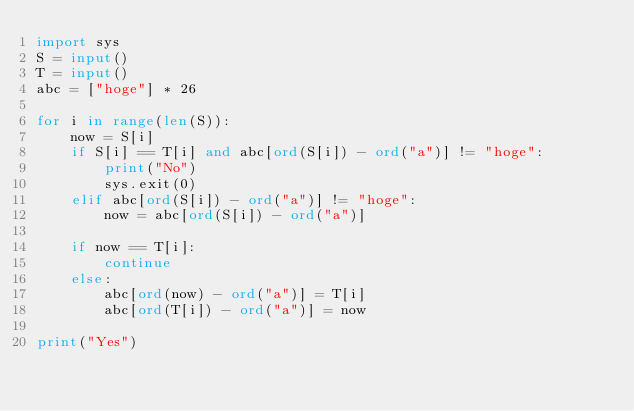<code> <loc_0><loc_0><loc_500><loc_500><_Python_>import sys
S = input()
T = input()
abc = ["hoge"] * 26

for i in range(len(S)):
    now = S[i]
    if S[i] == T[i] and abc[ord(S[i]) - ord("a")] != "hoge":
        print("No")
        sys.exit(0)
    elif abc[ord(S[i]) - ord("a")] != "hoge":
        now = abc[ord(S[i]) - ord("a")]

    if now == T[i]:
        continue
    else:
        abc[ord(now) - ord("a")] = T[i]
        abc[ord(T[i]) - ord("a")] = now

print("Yes") 

</code> 